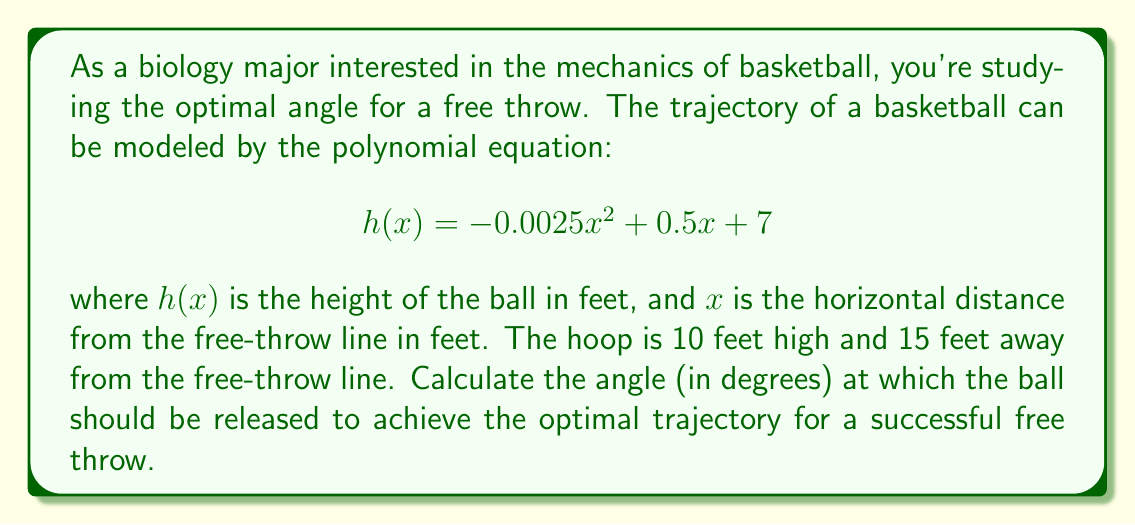Help me with this question. To solve this problem, we'll follow these steps:

1) First, we need to find the derivative of the function to determine the slope of the trajectory at the release point (x = 0):

   $$h'(x) = -0.005x + 0.5$$

2) At x = 0, the slope is:
   
   $$h'(0) = 0.5$$

3) The slope at the release point represents the tangent of the release angle. We can use the arctangent function to find this angle:

   $$\theta = \arctan(0.5)$$

4) Convert the angle from radians to degrees:

   $$\theta_{degrees} = \arctan(0.5) \cdot \frac{180}{\pi}$$

5) Calculate the result:

   $$\theta_{degrees} \approx 26.57°$$

This angle represents the optimal release angle for the given trajectory. It's worth noting that this angle is similar to the actual optimal angle used by professional basketball players, which is typically around 52° from the horizontal (or 38° above the horizontal, which is complementary to our calculated angle).

[asy]
import graph;
size(200,150);
real f(real x) {return -0.0025*x^2 + 0.5*x + 7;}
draw(graph(f,0,15),blue);
draw((0,0)--(15,0),black);
draw((0,0)--(0,12),black);
dot((15,10),red);
draw((0,7)--(15,10),dashed);
label("Hoop",(15,10),E);
label("Free-throw line",(0,0),W);
[/asy]

The diagram above illustrates the trajectory of the ball (blue curve) from the free-throw line to the hoop.
Answer: The optimal angle for the free throw is approximately 26.57°. 